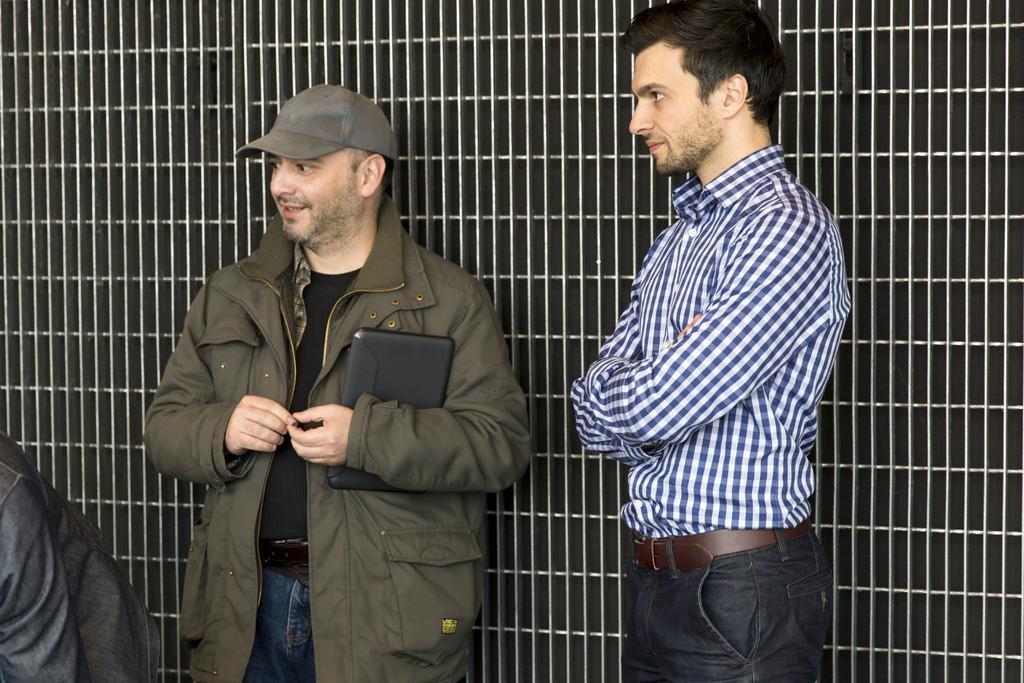Please provide a concise description of this image. In this image, there are two persons standing. In the background, I can see the iron grilles. 